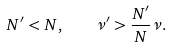Convert formula to latex. <formula><loc_0><loc_0><loc_500><loc_500>N ^ { \prime } < N , \quad \nu ^ { \prime } > \frac { N ^ { \prime } } { N } \nu .</formula> 